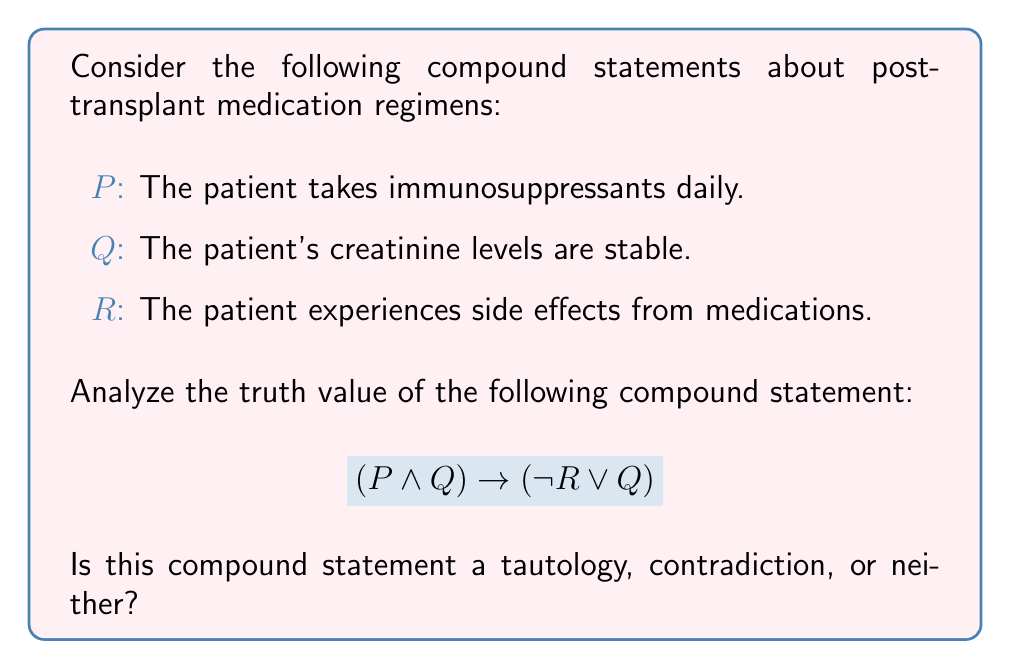Help me with this question. Let's approach this step-by-step:

1) First, we need to understand what makes a statement a tautology or a contradiction:
   - A tautology is always true, regardless of the truth values of its components.
   - A contradiction is always false, regardless of the truth values of its components.
   - If it's neither always true nor always false, it's neither a tautology nor a contradiction.

2) To determine which category our statement falls into, we need to evaluate it for all possible combinations of truth values for P, Q, and R.

3) Let's create a truth table:

   $$\begin{array}{|c|c|c|c|c|c|c|}
   \hline
   P & Q & R & P \land Q & \neg R & \neg R \lor Q & (P \land Q) \rightarrow (\neg R \lor Q) \\
   \hline
   T & T & T & T & F & T & T \\
   T & T & F & T & T & T & T \\
   T & F & T & F & F & F & T \\
   T & F & F & F & T & T & T \\
   F & T & T & F & F & T & T \\
   F & T & F & F & T & T & T \\
   F & F & T & F & F & F & T \\
   F & F & F & F & T & T & T \\
   \hline
   \end{array}$$

4) As we can see from the last column of the truth table, the compound statement is true for all possible combinations of P, Q, and R.

5) This means that regardless of whether the patient takes immunosuppressants daily, whether their creatinine levels are stable, or whether they experience side effects, the compound statement is always true.

6) Therefore, this compound statement is a tautology.
Answer: Tautology 